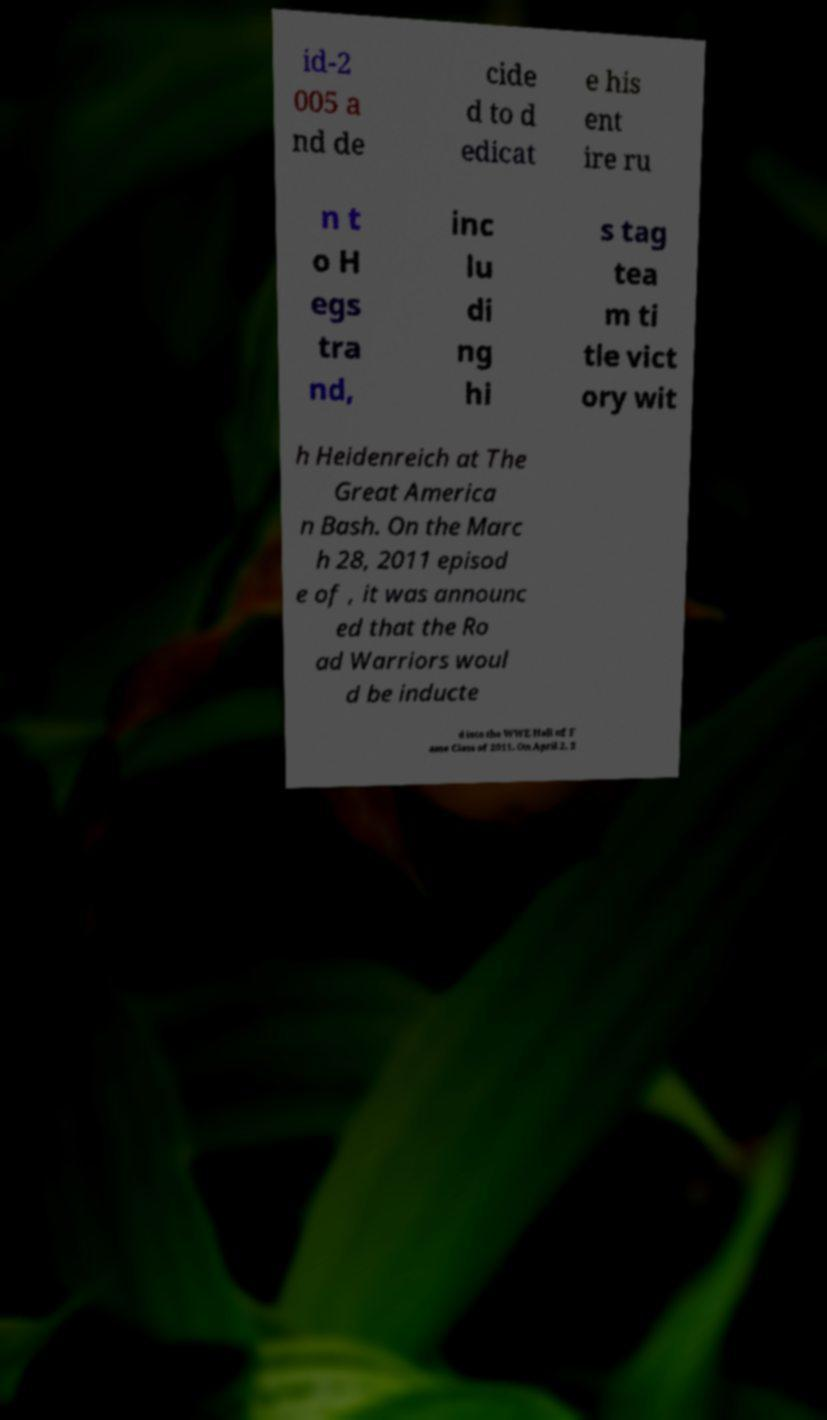Can you read and provide the text displayed in the image?This photo seems to have some interesting text. Can you extract and type it out for me? id-2 005 a nd de cide d to d edicat e his ent ire ru n t o H egs tra nd, inc lu di ng hi s tag tea m ti tle vict ory wit h Heidenreich at The Great America n Bash. On the Marc h 28, 2011 episod e of , it was announc ed that the Ro ad Warriors woul d be inducte d into the WWE Hall of F ame Class of 2011. On April 2, 2 